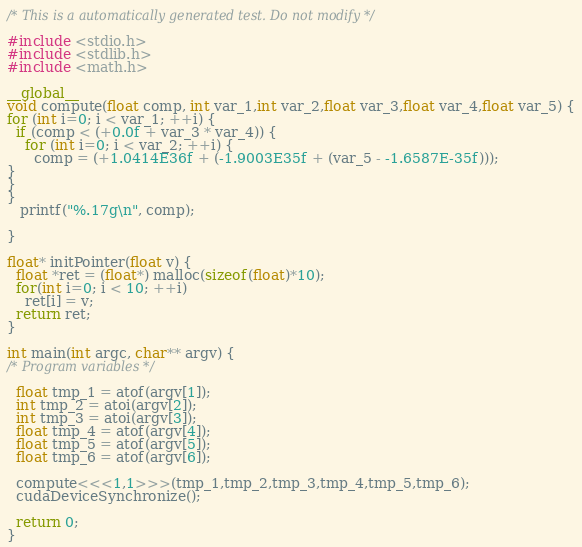<code> <loc_0><loc_0><loc_500><loc_500><_Cuda_>
/* This is a automatically generated test. Do not modify */

#include <stdio.h>
#include <stdlib.h>
#include <math.h>

__global__
void compute(float comp, int var_1,int var_2,float var_3,float var_4,float var_5) {
for (int i=0; i < var_1; ++i) {
  if (comp < (+0.0f + var_3 * var_4)) {
    for (int i=0; i < var_2; ++i) {
      comp = (+1.0414E36f + (-1.9003E35f + (var_5 - -1.6587E-35f)));
}
}
}
   printf("%.17g\n", comp);

}

float* initPointer(float v) {
  float *ret = (float*) malloc(sizeof(float)*10);
  for(int i=0; i < 10; ++i)
    ret[i] = v;
  return ret;
}

int main(int argc, char** argv) {
/* Program variables */

  float tmp_1 = atof(argv[1]);
  int tmp_2 = atoi(argv[2]);
  int tmp_3 = atoi(argv[3]);
  float tmp_4 = atof(argv[4]);
  float tmp_5 = atof(argv[5]);
  float tmp_6 = atof(argv[6]);

  compute<<<1,1>>>(tmp_1,tmp_2,tmp_3,tmp_4,tmp_5,tmp_6);
  cudaDeviceSynchronize();

  return 0;
}
</code> 